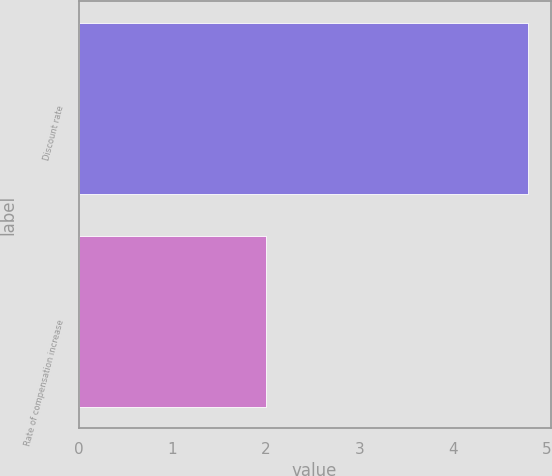Convert chart to OTSL. <chart><loc_0><loc_0><loc_500><loc_500><bar_chart><fcel>Discount rate<fcel>Rate of compensation increase<nl><fcel>4.8<fcel>2<nl></chart> 